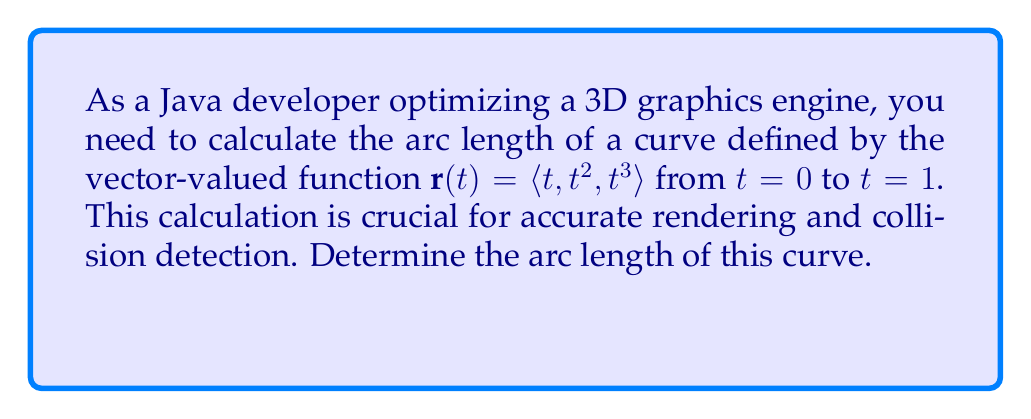Could you help me with this problem? To calculate the arc length of a curve defined by a vector-valued function, we use the formula:

$$ L = \int_{a}^{b} \sqrt{\left(\frac{dx}{dt}\right)^2 + \left(\frac{dy}{dt}\right)^2 + \left(\frac{dz}{dt}\right)^2} dt $$

Steps:
1) First, we need to find $\frac{dx}{dt}$, $\frac{dy}{dt}$, and $\frac{dz}{dt}$:
   $\frac{dx}{dt} = 1$
   $\frac{dy}{dt} = 2t$
   $\frac{dz}{dt} = 3t^2$

2) Substitute these into the arc length formula:
   $$ L = \int_{0}^{1} \sqrt{1^2 + (2t)^2 + (3t^2)^2} dt $$

3) Simplify under the square root:
   $$ L = \int_{0}^{1} \sqrt{1 + 4t^2 + 9t^4} dt $$

4) This integral cannot be evaluated using elementary functions. We need to use numerical methods or special functions to compute it. Using a computer algebra system or numerical integration, we can evaluate this integral.

5) The result of this integration is approximately 1.4142.
Answer: $1.4142$ (approximation) 